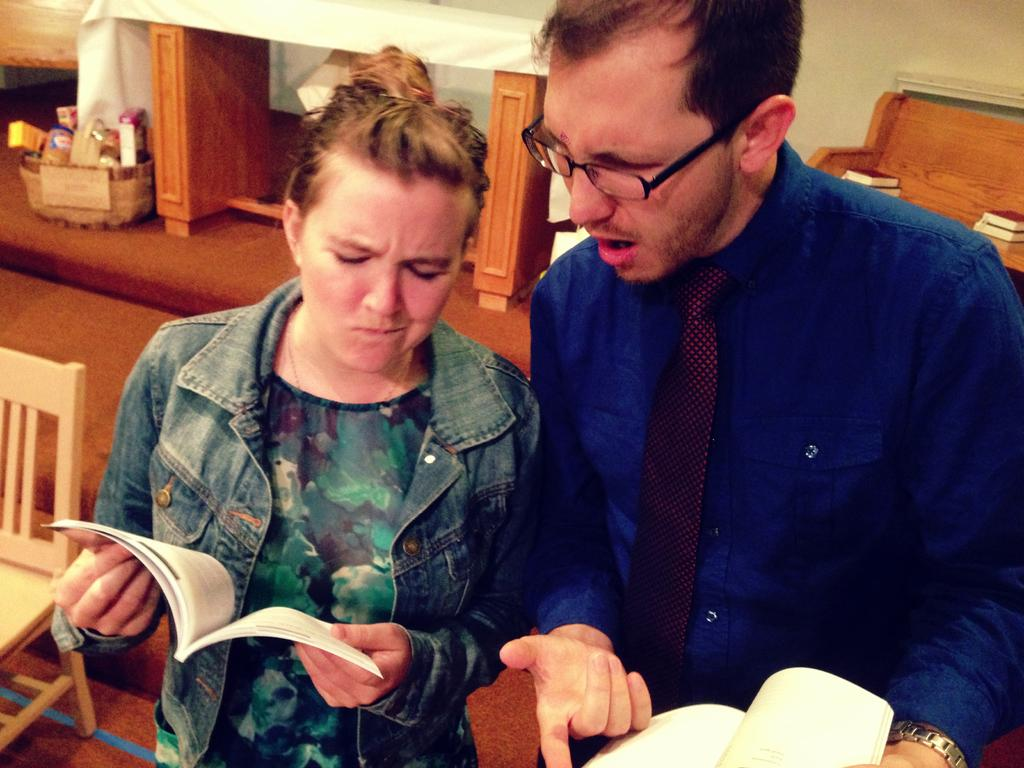How many people are in the image? There are two people standing in the image. What are the people holding? The people are holding books. What can be seen in the background of the image? There is a chair, a table, a wall, a basket, and other unspecified objects in the background of the image. What page of the book are the people waiting for approval on in the image? There is no indication in the image that the people are waiting for approval or that they are on a specific page of the book. 